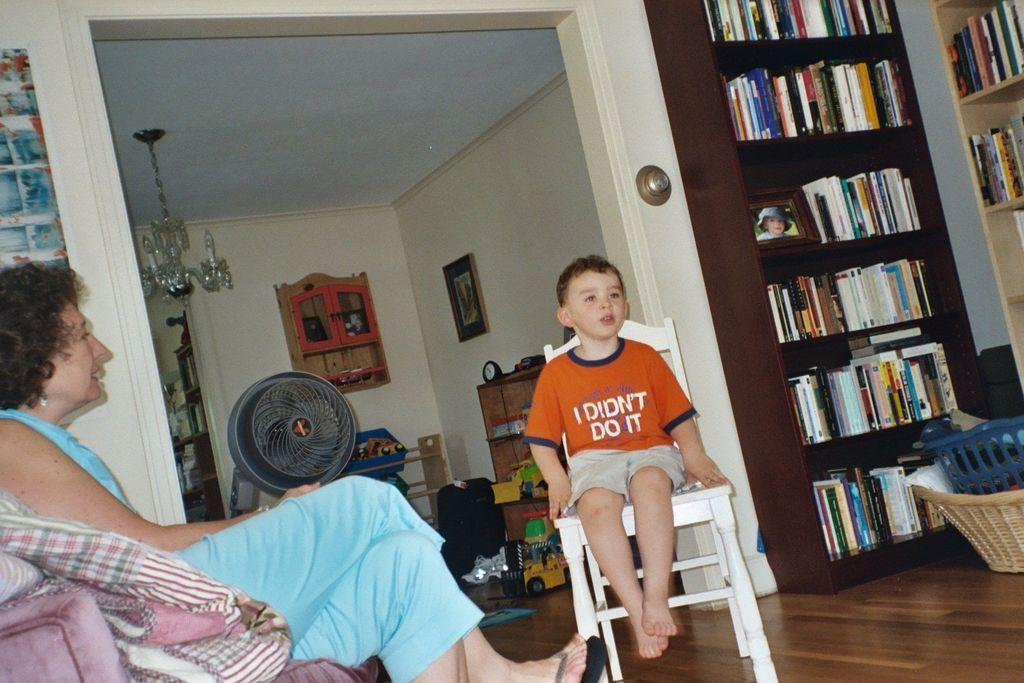Who are the people in the image? There is a woman and a boy in the image. What are they doing in the image? They are sitting on a chair. What can be seen in the room where they are sitting? The room contains books, a rack, toys, a fan, lights, and a table. What is the color of the background in the image? The background of the image is white. Can you see any dinosaurs in the room? No, there are no dinosaurs present in the image. What type of whip is being used by the woman in the image? There is no whip present in the image. 